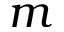Convert formula to latex. <formula><loc_0><loc_0><loc_500><loc_500>m</formula> 